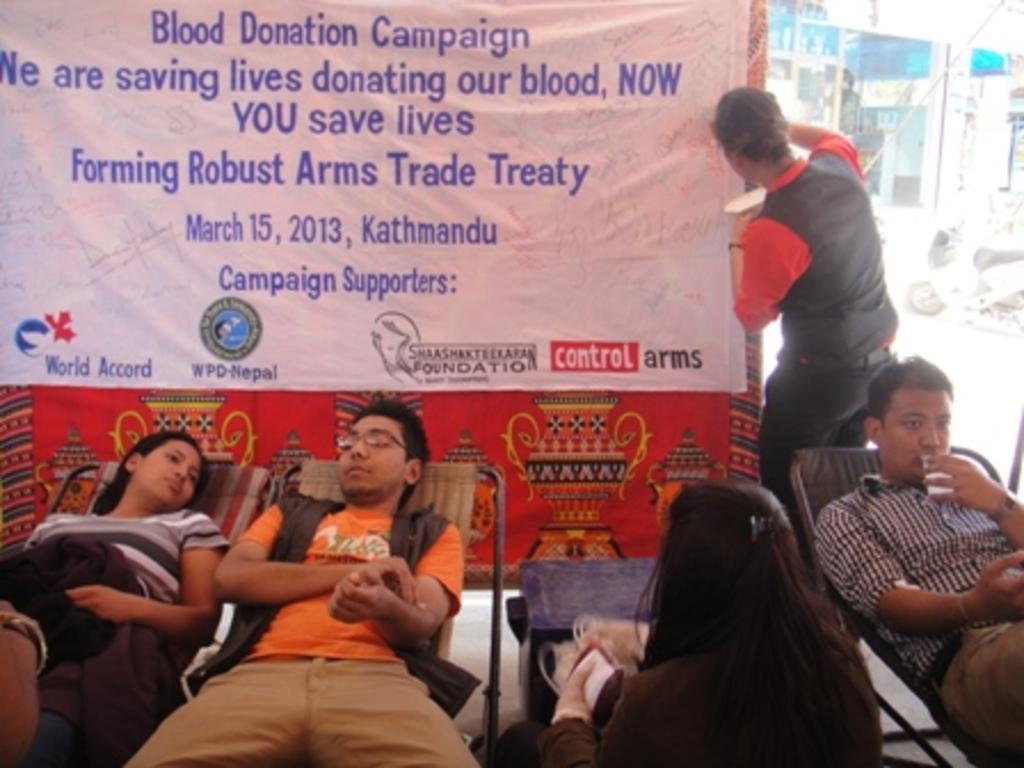Please provide a concise description of this image. There are three people sitting on chairs. On the right a person is holding glass and drinking. He is wearing a watch. Another person is wearing a specs. In the front a lady is sitting and holding a cover. In the background there is banner and a person is standing near the banner. 